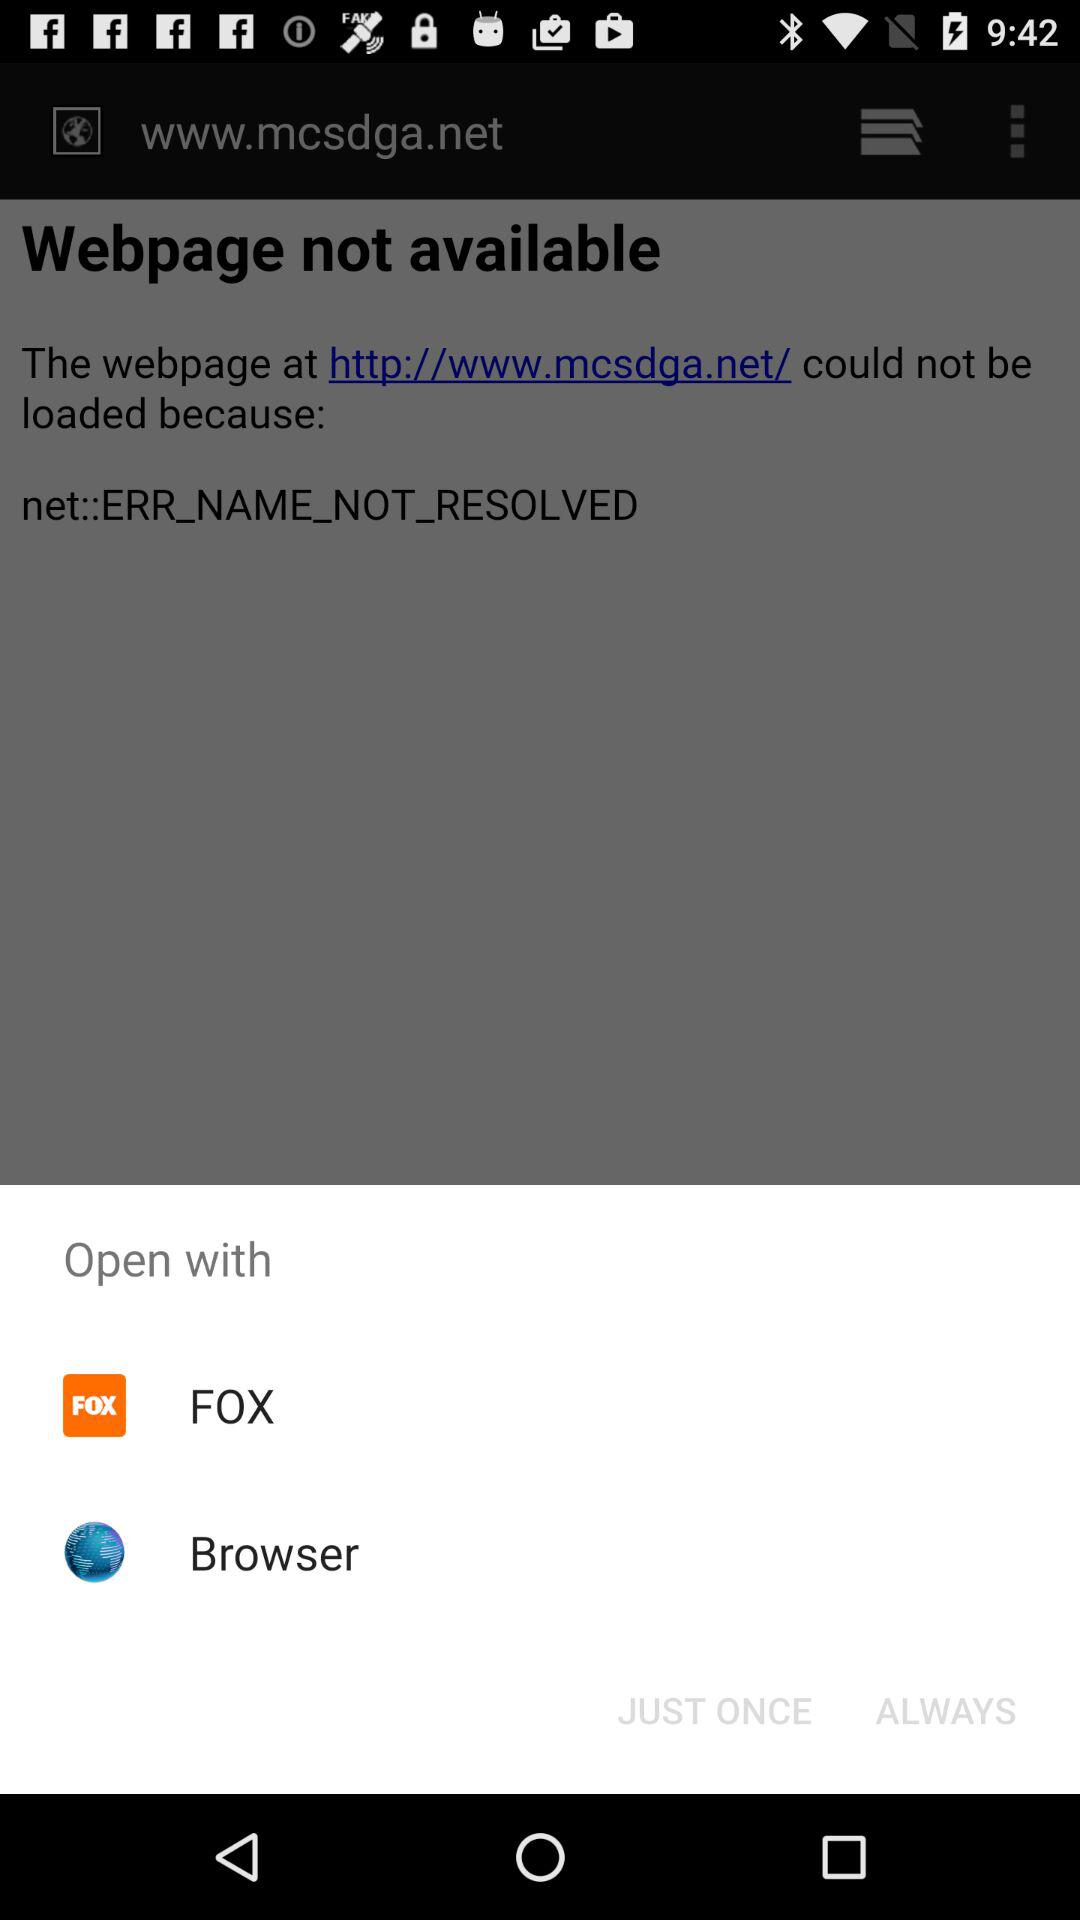How many open with options are there?
Answer the question using a single word or phrase. 2 